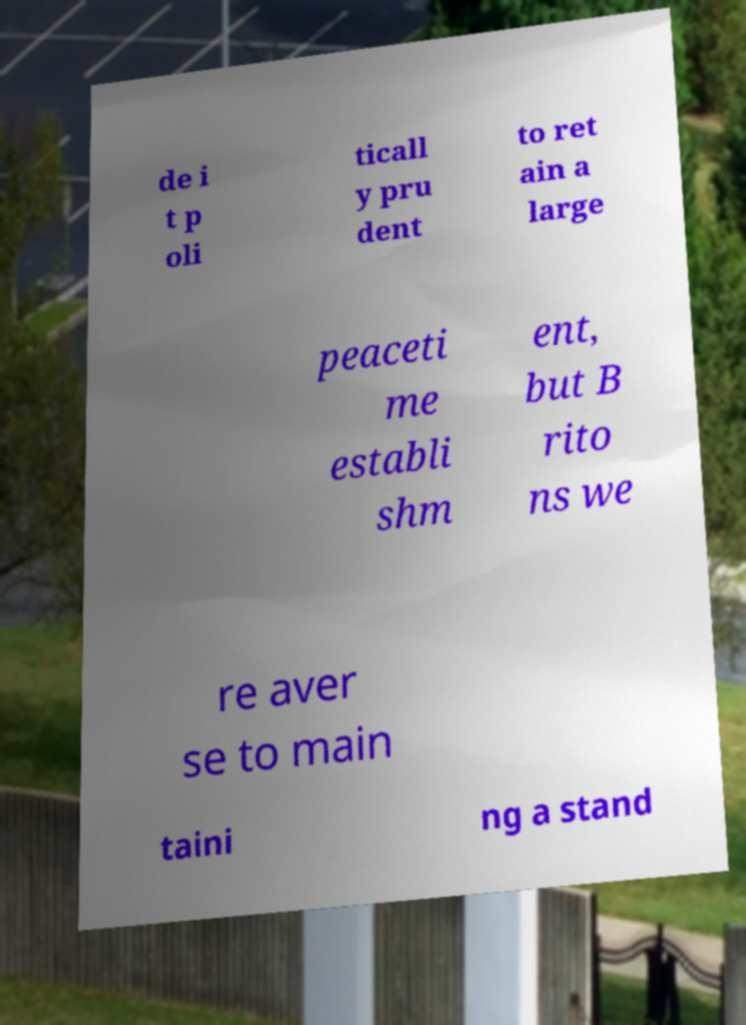Could you assist in decoding the text presented in this image and type it out clearly? de i t p oli ticall y pru dent to ret ain a large peaceti me establi shm ent, but B rito ns we re aver se to main taini ng a stand 